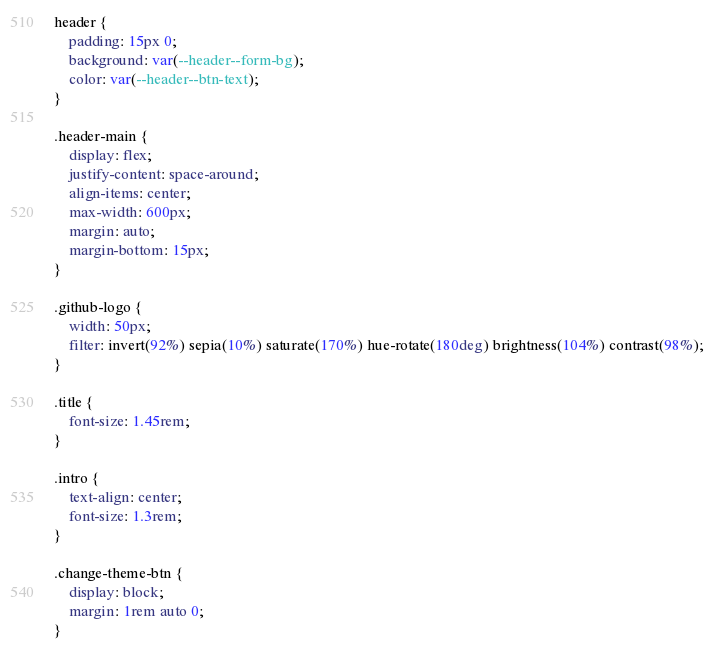<code> <loc_0><loc_0><loc_500><loc_500><_CSS_>header {
    padding: 15px 0;
    background: var(--header--form-bg);
    color: var(--header--btn-text);
}

.header-main {
    display: flex;
    justify-content: space-around;
    align-items: center;
    max-width: 600px;
    margin: auto;
    margin-bottom: 15px;
}

.github-logo {
    width: 50px;
    filter: invert(92%) sepia(10%) saturate(170%) hue-rotate(180deg) brightness(104%) contrast(98%);
}

.title {
    font-size: 1.45rem;
}

.intro {
    text-align: center;
    font-size: 1.3rem;
}

.change-theme-btn {
    display: block;
    margin: 1rem auto 0;
}</code> 